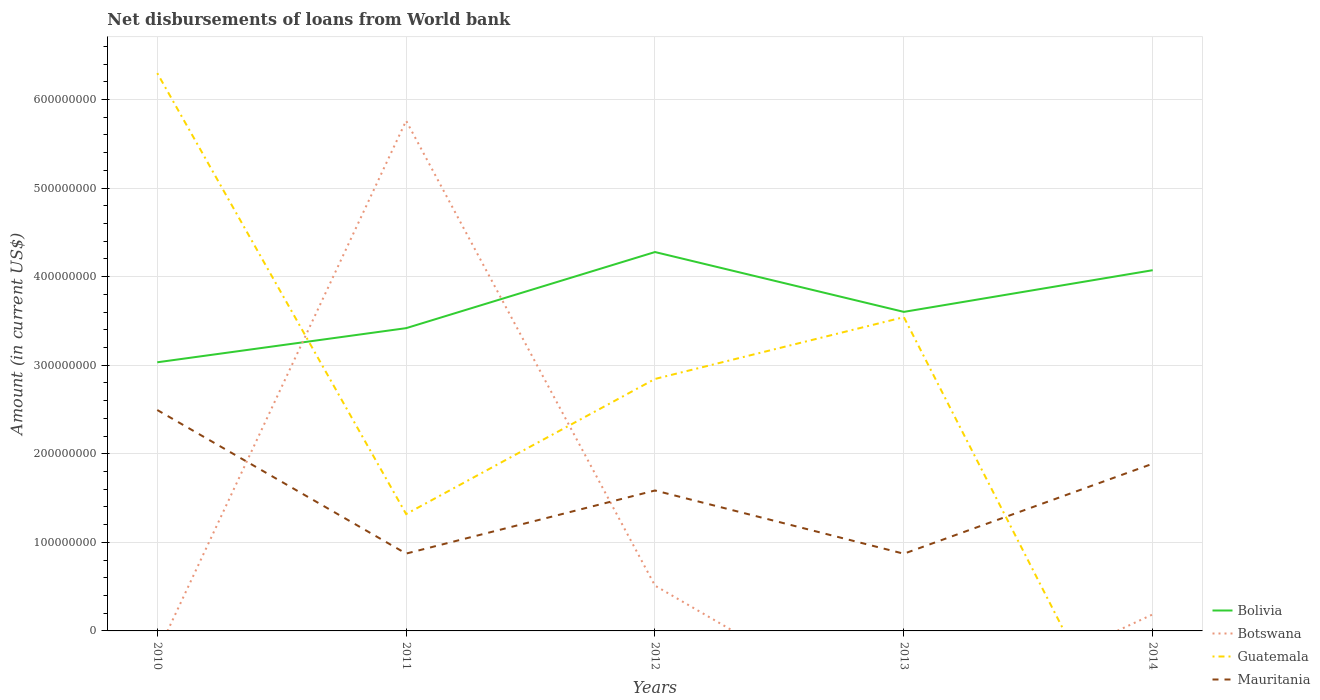Does the line corresponding to Bolivia intersect with the line corresponding to Mauritania?
Your response must be concise. No. Is the number of lines equal to the number of legend labels?
Your answer should be compact. No. Across all years, what is the maximum amount of loan disbursed from World Bank in Bolivia?
Provide a succinct answer. 3.03e+08. What is the total amount of loan disbursed from World Bank in Mauritania in the graph?
Provide a short and direct response. 1.62e+08. What is the difference between the highest and the second highest amount of loan disbursed from World Bank in Guatemala?
Ensure brevity in your answer.  6.30e+08. What is the difference between the highest and the lowest amount of loan disbursed from World Bank in Guatemala?
Provide a succinct answer. 3. Is the amount of loan disbursed from World Bank in Botswana strictly greater than the amount of loan disbursed from World Bank in Bolivia over the years?
Provide a short and direct response. No. How many lines are there?
Provide a short and direct response. 4. What is the difference between two consecutive major ticks on the Y-axis?
Your answer should be very brief. 1.00e+08. Does the graph contain any zero values?
Keep it short and to the point. Yes. Where does the legend appear in the graph?
Your response must be concise. Bottom right. How are the legend labels stacked?
Offer a very short reply. Vertical. What is the title of the graph?
Give a very brief answer. Net disbursements of loans from World bank. What is the label or title of the Y-axis?
Make the answer very short. Amount (in current US$). What is the Amount (in current US$) in Bolivia in 2010?
Keep it short and to the point. 3.03e+08. What is the Amount (in current US$) of Guatemala in 2010?
Provide a succinct answer. 6.30e+08. What is the Amount (in current US$) in Mauritania in 2010?
Your answer should be compact. 2.49e+08. What is the Amount (in current US$) in Bolivia in 2011?
Provide a short and direct response. 3.42e+08. What is the Amount (in current US$) of Botswana in 2011?
Offer a terse response. 5.76e+08. What is the Amount (in current US$) of Guatemala in 2011?
Keep it short and to the point. 1.32e+08. What is the Amount (in current US$) of Mauritania in 2011?
Your answer should be compact. 8.73e+07. What is the Amount (in current US$) in Bolivia in 2012?
Ensure brevity in your answer.  4.28e+08. What is the Amount (in current US$) of Botswana in 2012?
Give a very brief answer. 5.11e+07. What is the Amount (in current US$) of Guatemala in 2012?
Offer a very short reply. 2.84e+08. What is the Amount (in current US$) of Mauritania in 2012?
Make the answer very short. 1.59e+08. What is the Amount (in current US$) of Bolivia in 2013?
Your answer should be very brief. 3.60e+08. What is the Amount (in current US$) in Guatemala in 2013?
Your answer should be very brief. 3.54e+08. What is the Amount (in current US$) in Mauritania in 2013?
Offer a very short reply. 8.72e+07. What is the Amount (in current US$) in Bolivia in 2014?
Provide a succinct answer. 4.07e+08. What is the Amount (in current US$) in Botswana in 2014?
Provide a short and direct response. 1.87e+07. What is the Amount (in current US$) of Guatemala in 2014?
Keep it short and to the point. 0. What is the Amount (in current US$) in Mauritania in 2014?
Offer a very short reply. 1.89e+08. Across all years, what is the maximum Amount (in current US$) of Bolivia?
Your response must be concise. 4.28e+08. Across all years, what is the maximum Amount (in current US$) of Botswana?
Your response must be concise. 5.76e+08. Across all years, what is the maximum Amount (in current US$) in Guatemala?
Provide a short and direct response. 6.30e+08. Across all years, what is the maximum Amount (in current US$) of Mauritania?
Offer a terse response. 2.49e+08. Across all years, what is the minimum Amount (in current US$) of Bolivia?
Provide a short and direct response. 3.03e+08. Across all years, what is the minimum Amount (in current US$) of Guatemala?
Your response must be concise. 0. Across all years, what is the minimum Amount (in current US$) in Mauritania?
Provide a succinct answer. 8.72e+07. What is the total Amount (in current US$) in Bolivia in the graph?
Provide a succinct answer. 1.84e+09. What is the total Amount (in current US$) in Botswana in the graph?
Make the answer very short. 6.46e+08. What is the total Amount (in current US$) in Guatemala in the graph?
Offer a very short reply. 1.40e+09. What is the total Amount (in current US$) of Mauritania in the graph?
Keep it short and to the point. 7.71e+08. What is the difference between the Amount (in current US$) of Bolivia in 2010 and that in 2011?
Your answer should be compact. -3.85e+07. What is the difference between the Amount (in current US$) in Guatemala in 2010 and that in 2011?
Offer a very short reply. 4.98e+08. What is the difference between the Amount (in current US$) of Mauritania in 2010 and that in 2011?
Ensure brevity in your answer.  1.62e+08. What is the difference between the Amount (in current US$) of Bolivia in 2010 and that in 2012?
Offer a very short reply. -1.24e+08. What is the difference between the Amount (in current US$) in Guatemala in 2010 and that in 2012?
Ensure brevity in your answer.  3.45e+08. What is the difference between the Amount (in current US$) of Mauritania in 2010 and that in 2012?
Make the answer very short. 9.09e+07. What is the difference between the Amount (in current US$) in Bolivia in 2010 and that in 2013?
Your answer should be compact. -5.69e+07. What is the difference between the Amount (in current US$) of Guatemala in 2010 and that in 2013?
Offer a very short reply. 2.75e+08. What is the difference between the Amount (in current US$) of Mauritania in 2010 and that in 2013?
Your response must be concise. 1.62e+08. What is the difference between the Amount (in current US$) in Bolivia in 2010 and that in 2014?
Provide a short and direct response. -1.04e+08. What is the difference between the Amount (in current US$) of Mauritania in 2010 and that in 2014?
Your answer should be very brief. 6.06e+07. What is the difference between the Amount (in current US$) of Bolivia in 2011 and that in 2012?
Offer a terse response. -8.59e+07. What is the difference between the Amount (in current US$) in Botswana in 2011 and that in 2012?
Offer a very short reply. 5.25e+08. What is the difference between the Amount (in current US$) of Guatemala in 2011 and that in 2012?
Make the answer very short. -1.53e+08. What is the difference between the Amount (in current US$) of Mauritania in 2011 and that in 2012?
Give a very brief answer. -7.13e+07. What is the difference between the Amount (in current US$) of Bolivia in 2011 and that in 2013?
Your answer should be compact. -1.84e+07. What is the difference between the Amount (in current US$) of Guatemala in 2011 and that in 2013?
Your response must be concise. -2.22e+08. What is the difference between the Amount (in current US$) in Mauritania in 2011 and that in 2013?
Make the answer very short. 1.45e+05. What is the difference between the Amount (in current US$) of Bolivia in 2011 and that in 2014?
Provide a short and direct response. -6.54e+07. What is the difference between the Amount (in current US$) in Botswana in 2011 and that in 2014?
Keep it short and to the point. 5.57e+08. What is the difference between the Amount (in current US$) of Mauritania in 2011 and that in 2014?
Ensure brevity in your answer.  -1.01e+08. What is the difference between the Amount (in current US$) of Bolivia in 2012 and that in 2013?
Provide a short and direct response. 6.76e+07. What is the difference between the Amount (in current US$) of Guatemala in 2012 and that in 2013?
Give a very brief answer. -6.98e+07. What is the difference between the Amount (in current US$) of Mauritania in 2012 and that in 2013?
Your response must be concise. 7.14e+07. What is the difference between the Amount (in current US$) of Bolivia in 2012 and that in 2014?
Your answer should be very brief. 2.05e+07. What is the difference between the Amount (in current US$) of Botswana in 2012 and that in 2014?
Give a very brief answer. 3.25e+07. What is the difference between the Amount (in current US$) in Mauritania in 2012 and that in 2014?
Ensure brevity in your answer.  -3.02e+07. What is the difference between the Amount (in current US$) in Bolivia in 2013 and that in 2014?
Your answer should be very brief. -4.71e+07. What is the difference between the Amount (in current US$) of Mauritania in 2013 and that in 2014?
Your answer should be compact. -1.02e+08. What is the difference between the Amount (in current US$) in Bolivia in 2010 and the Amount (in current US$) in Botswana in 2011?
Provide a short and direct response. -2.73e+08. What is the difference between the Amount (in current US$) in Bolivia in 2010 and the Amount (in current US$) in Guatemala in 2011?
Offer a terse response. 1.71e+08. What is the difference between the Amount (in current US$) in Bolivia in 2010 and the Amount (in current US$) in Mauritania in 2011?
Offer a very short reply. 2.16e+08. What is the difference between the Amount (in current US$) of Guatemala in 2010 and the Amount (in current US$) of Mauritania in 2011?
Make the answer very short. 5.42e+08. What is the difference between the Amount (in current US$) in Bolivia in 2010 and the Amount (in current US$) in Botswana in 2012?
Your response must be concise. 2.52e+08. What is the difference between the Amount (in current US$) of Bolivia in 2010 and the Amount (in current US$) of Guatemala in 2012?
Your answer should be compact. 1.88e+07. What is the difference between the Amount (in current US$) in Bolivia in 2010 and the Amount (in current US$) in Mauritania in 2012?
Provide a short and direct response. 1.45e+08. What is the difference between the Amount (in current US$) of Guatemala in 2010 and the Amount (in current US$) of Mauritania in 2012?
Ensure brevity in your answer.  4.71e+08. What is the difference between the Amount (in current US$) in Bolivia in 2010 and the Amount (in current US$) in Guatemala in 2013?
Provide a succinct answer. -5.10e+07. What is the difference between the Amount (in current US$) in Bolivia in 2010 and the Amount (in current US$) in Mauritania in 2013?
Make the answer very short. 2.16e+08. What is the difference between the Amount (in current US$) in Guatemala in 2010 and the Amount (in current US$) in Mauritania in 2013?
Provide a succinct answer. 5.43e+08. What is the difference between the Amount (in current US$) in Bolivia in 2010 and the Amount (in current US$) in Botswana in 2014?
Your answer should be compact. 2.85e+08. What is the difference between the Amount (in current US$) of Bolivia in 2010 and the Amount (in current US$) of Mauritania in 2014?
Make the answer very short. 1.14e+08. What is the difference between the Amount (in current US$) of Guatemala in 2010 and the Amount (in current US$) of Mauritania in 2014?
Offer a very short reply. 4.41e+08. What is the difference between the Amount (in current US$) of Bolivia in 2011 and the Amount (in current US$) of Botswana in 2012?
Provide a short and direct response. 2.91e+08. What is the difference between the Amount (in current US$) of Bolivia in 2011 and the Amount (in current US$) of Guatemala in 2012?
Your response must be concise. 5.73e+07. What is the difference between the Amount (in current US$) of Bolivia in 2011 and the Amount (in current US$) of Mauritania in 2012?
Your answer should be very brief. 1.83e+08. What is the difference between the Amount (in current US$) in Botswana in 2011 and the Amount (in current US$) in Guatemala in 2012?
Make the answer very short. 2.92e+08. What is the difference between the Amount (in current US$) in Botswana in 2011 and the Amount (in current US$) in Mauritania in 2012?
Your answer should be compact. 4.17e+08. What is the difference between the Amount (in current US$) of Guatemala in 2011 and the Amount (in current US$) of Mauritania in 2012?
Your response must be concise. -2.66e+07. What is the difference between the Amount (in current US$) of Bolivia in 2011 and the Amount (in current US$) of Guatemala in 2013?
Provide a succinct answer. -1.24e+07. What is the difference between the Amount (in current US$) of Bolivia in 2011 and the Amount (in current US$) of Mauritania in 2013?
Provide a short and direct response. 2.55e+08. What is the difference between the Amount (in current US$) in Botswana in 2011 and the Amount (in current US$) in Guatemala in 2013?
Make the answer very short. 2.22e+08. What is the difference between the Amount (in current US$) in Botswana in 2011 and the Amount (in current US$) in Mauritania in 2013?
Ensure brevity in your answer.  4.89e+08. What is the difference between the Amount (in current US$) in Guatemala in 2011 and the Amount (in current US$) in Mauritania in 2013?
Offer a terse response. 4.48e+07. What is the difference between the Amount (in current US$) of Bolivia in 2011 and the Amount (in current US$) of Botswana in 2014?
Keep it short and to the point. 3.23e+08. What is the difference between the Amount (in current US$) of Bolivia in 2011 and the Amount (in current US$) of Mauritania in 2014?
Your answer should be very brief. 1.53e+08. What is the difference between the Amount (in current US$) of Botswana in 2011 and the Amount (in current US$) of Mauritania in 2014?
Make the answer very short. 3.87e+08. What is the difference between the Amount (in current US$) of Guatemala in 2011 and the Amount (in current US$) of Mauritania in 2014?
Your answer should be compact. -5.69e+07. What is the difference between the Amount (in current US$) of Bolivia in 2012 and the Amount (in current US$) of Guatemala in 2013?
Provide a succinct answer. 7.35e+07. What is the difference between the Amount (in current US$) of Bolivia in 2012 and the Amount (in current US$) of Mauritania in 2013?
Make the answer very short. 3.41e+08. What is the difference between the Amount (in current US$) of Botswana in 2012 and the Amount (in current US$) of Guatemala in 2013?
Offer a terse response. -3.03e+08. What is the difference between the Amount (in current US$) of Botswana in 2012 and the Amount (in current US$) of Mauritania in 2013?
Offer a terse response. -3.60e+07. What is the difference between the Amount (in current US$) of Guatemala in 2012 and the Amount (in current US$) of Mauritania in 2013?
Provide a short and direct response. 1.97e+08. What is the difference between the Amount (in current US$) in Bolivia in 2012 and the Amount (in current US$) in Botswana in 2014?
Give a very brief answer. 4.09e+08. What is the difference between the Amount (in current US$) in Bolivia in 2012 and the Amount (in current US$) in Mauritania in 2014?
Your response must be concise. 2.39e+08. What is the difference between the Amount (in current US$) in Botswana in 2012 and the Amount (in current US$) in Mauritania in 2014?
Provide a succinct answer. -1.38e+08. What is the difference between the Amount (in current US$) in Guatemala in 2012 and the Amount (in current US$) in Mauritania in 2014?
Your answer should be very brief. 9.57e+07. What is the difference between the Amount (in current US$) of Bolivia in 2013 and the Amount (in current US$) of Botswana in 2014?
Provide a succinct answer. 3.42e+08. What is the difference between the Amount (in current US$) in Bolivia in 2013 and the Amount (in current US$) in Mauritania in 2014?
Your answer should be compact. 1.71e+08. What is the difference between the Amount (in current US$) of Guatemala in 2013 and the Amount (in current US$) of Mauritania in 2014?
Your answer should be very brief. 1.65e+08. What is the average Amount (in current US$) in Bolivia per year?
Offer a very short reply. 3.68e+08. What is the average Amount (in current US$) in Botswana per year?
Give a very brief answer. 1.29e+08. What is the average Amount (in current US$) of Guatemala per year?
Your answer should be very brief. 2.80e+08. What is the average Amount (in current US$) of Mauritania per year?
Your response must be concise. 1.54e+08. In the year 2010, what is the difference between the Amount (in current US$) of Bolivia and Amount (in current US$) of Guatemala?
Keep it short and to the point. -3.26e+08. In the year 2010, what is the difference between the Amount (in current US$) in Bolivia and Amount (in current US$) in Mauritania?
Give a very brief answer. 5.39e+07. In the year 2010, what is the difference between the Amount (in current US$) of Guatemala and Amount (in current US$) of Mauritania?
Keep it short and to the point. 3.80e+08. In the year 2011, what is the difference between the Amount (in current US$) of Bolivia and Amount (in current US$) of Botswana?
Provide a short and direct response. -2.34e+08. In the year 2011, what is the difference between the Amount (in current US$) of Bolivia and Amount (in current US$) of Guatemala?
Provide a short and direct response. 2.10e+08. In the year 2011, what is the difference between the Amount (in current US$) of Bolivia and Amount (in current US$) of Mauritania?
Your answer should be compact. 2.55e+08. In the year 2011, what is the difference between the Amount (in current US$) of Botswana and Amount (in current US$) of Guatemala?
Your response must be concise. 4.44e+08. In the year 2011, what is the difference between the Amount (in current US$) in Botswana and Amount (in current US$) in Mauritania?
Make the answer very short. 4.89e+08. In the year 2011, what is the difference between the Amount (in current US$) in Guatemala and Amount (in current US$) in Mauritania?
Keep it short and to the point. 4.46e+07. In the year 2012, what is the difference between the Amount (in current US$) of Bolivia and Amount (in current US$) of Botswana?
Give a very brief answer. 3.77e+08. In the year 2012, what is the difference between the Amount (in current US$) in Bolivia and Amount (in current US$) in Guatemala?
Offer a very short reply. 1.43e+08. In the year 2012, what is the difference between the Amount (in current US$) in Bolivia and Amount (in current US$) in Mauritania?
Provide a short and direct response. 2.69e+08. In the year 2012, what is the difference between the Amount (in current US$) in Botswana and Amount (in current US$) in Guatemala?
Make the answer very short. -2.33e+08. In the year 2012, what is the difference between the Amount (in current US$) of Botswana and Amount (in current US$) of Mauritania?
Ensure brevity in your answer.  -1.07e+08. In the year 2012, what is the difference between the Amount (in current US$) of Guatemala and Amount (in current US$) of Mauritania?
Keep it short and to the point. 1.26e+08. In the year 2013, what is the difference between the Amount (in current US$) of Bolivia and Amount (in current US$) of Guatemala?
Your response must be concise. 5.95e+06. In the year 2013, what is the difference between the Amount (in current US$) in Bolivia and Amount (in current US$) in Mauritania?
Your answer should be very brief. 2.73e+08. In the year 2013, what is the difference between the Amount (in current US$) in Guatemala and Amount (in current US$) in Mauritania?
Offer a very short reply. 2.67e+08. In the year 2014, what is the difference between the Amount (in current US$) of Bolivia and Amount (in current US$) of Botswana?
Your answer should be compact. 3.89e+08. In the year 2014, what is the difference between the Amount (in current US$) of Bolivia and Amount (in current US$) of Mauritania?
Provide a succinct answer. 2.18e+08. In the year 2014, what is the difference between the Amount (in current US$) in Botswana and Amount (in current US$) in Mauritania?
Your response must be concise. -1.70e+08. What is the ratio of the Amount (in current US$) of Bolivia in 2010 to that in 2011?
Offer a terse response. 0.89. What is the ratio of the Amount (in current US$) in Guatemala in 2010 to that in 2011?
Ensure brevity in your answer.  4.77. What is the ratio of the Amount (in current US$) in Mauritania in 2010 to that in 2011?
Give a very brief answer. 2.86. What is the ratio of the Amount (in current US$) in Bolivia in 2010 to that in 2012?
Offer a very short reply. 0.71. What is the ratio of the Amount (in current US$) in Guatemala in 2010 to that in 2012?
Offer a terse response. 2.21. What is the ratio of the Amount (in current US$) of Mauritania in 2010 to that in 2012?
Give a very brief answer. 1.57. What is the ratio of the Amount (in current US$) of Bolivia in 2010 to that in 2013?
Offer a terse response. 0.84. What is the ratio of the Amount (in current US$) in Guatemala in 2010 to that in 2013?
Your response must be concise. 1.78. What is the ratio of the Amount (in current US$) of Mauritania in 2010 to that in 2013?
Your response must be concise. 2.86. What is the ratio of the Amount (in current US$) in Bolivia in 2010 to that in 2014?
Ensure brevity in your answer.  0.74. What is the ratio of the Amount (in current US$) of Mauritania in 2010 to that in 2014?
Give a very brief answer. 1.32. What is the ratio of the Amount (in current US$) in Bolivia in 2011 to that in 2012?
Keep it short and to the point. 0.8. What is the ratio of the Amount (in current US$) in Botswana in 2011 to that in 2012?
Your answer should be compact. 11.27. What is the ratio of the Amount (in current US$) in Guatemala in 2011 to that in 2012?
Provide a short and direct response. 0.46. What is the ratio of the Amount (in current US$) in Mauritania in 2011 to that in 2012?
Offer a very short reply. 0.55. What is the ratio of the Amount (in current US$) in Bolivia in 2011 to that in 2013?
Give a very brief answer. 0.95. What is the ratio of the Amount (in current US$) of Guatemala in 2011 to that in 2013?
Offer a terse response. 0.37. What is the ratio of the Amount (in current US$) in Bolivia in 2011 to that in 2014?
Your answer should be very brief. 0.84. What is the ratio of the Amount (in current US$) of Botswana in 2011 to that in 2014?
Make the answer very short. 30.85. What is the ratio of the Amount (in current US$) of Mauritania in 2011 to that in 2014?
Offer a terse response. 0.46. What is the ratio of the Amount (in current US$) of Bolivia in 2012 to that in 2013?
Offer a very short reply. 1.19. What is the ratio of the Amount (in current US$) of Guatemala in 2012 to that in 2013?
Ensure brevity in your answer.  0.8. What is the ratio of the Amount (in current US$) in Mauritania in 2012 to that in 2013?
Offer a very short reply. 1.82. What is the ratio of the Amount (in current US$) in Bolivia in 2012 to that in 2014?
Offer a terse response. 1.05. What is the ratio of the Amount (in current US$) in Botswana in 2012 to that in 2014?
Provide a succinct answer. 2.74. What is the ratio of the Amount (in current US$) of Mauritania in 2012 to that in 2014?
Ensure brevity in your answer.  0.84. What is the ratio of the Amount (in current US$) in Bolivia in 2013 to that in 2014?
Your answer should be compact. 0.88. What is the ratio of the Amount (in current US$) in Mauritania in 2013 to that in 2014?
Keep it short and to the point. 0.46. What is the difference between the highest and the second highest Amount (in current US$) of Bolivia?
Ensure brevity in your answer.  2.05e+07. What is the difference between the highest and the second highest Amount (in current US$) in Botswana?
Your answer should be very brief. 5.25e+08. What is the difference between the highest and the second highest Amount (in current US$) of Guatemala?
Provide a succinct answer. 2.75e+08. What is the difference between the highest and the second highest Amount (in current US$) of Mauritania?
Give a very brief answer. 6.06e+07. What is the difference between the highest and the lowest Amount (in current US$) in Bolivia?
Give a very brief answer. 1.24e+08. What is the difference between the highest and the lowest Amount (in current US$) of Botswana?
Make the answer very short. 5.76e+08. What is the difference between the highest and the lowest Amount (in current US$) in Guatemala?
Offer a terse response. 6.30e+08. What is the difference between the highest and the lowest Amount (in current US$) of Mauritania?
Provide a succinct answer. 1.62e+08. 